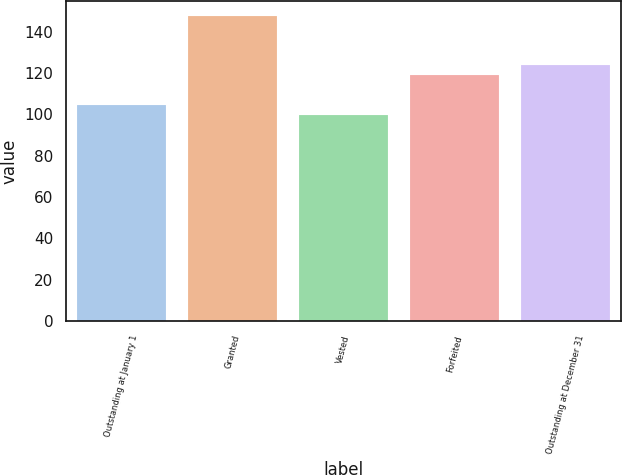Convert chart. <chart><loc_0><loc_0><loc_500><loc_500><bar_chart><fcel>Outstanding at January 1<fcel>Granted<fcel>Vested<fcel>Forfeited<fcel>Outstanding at December 31<nl><fcel>104.34<fcel>147.44<fcel>99.55<fcel>118.82<fcel>123.61<nl></chart> 